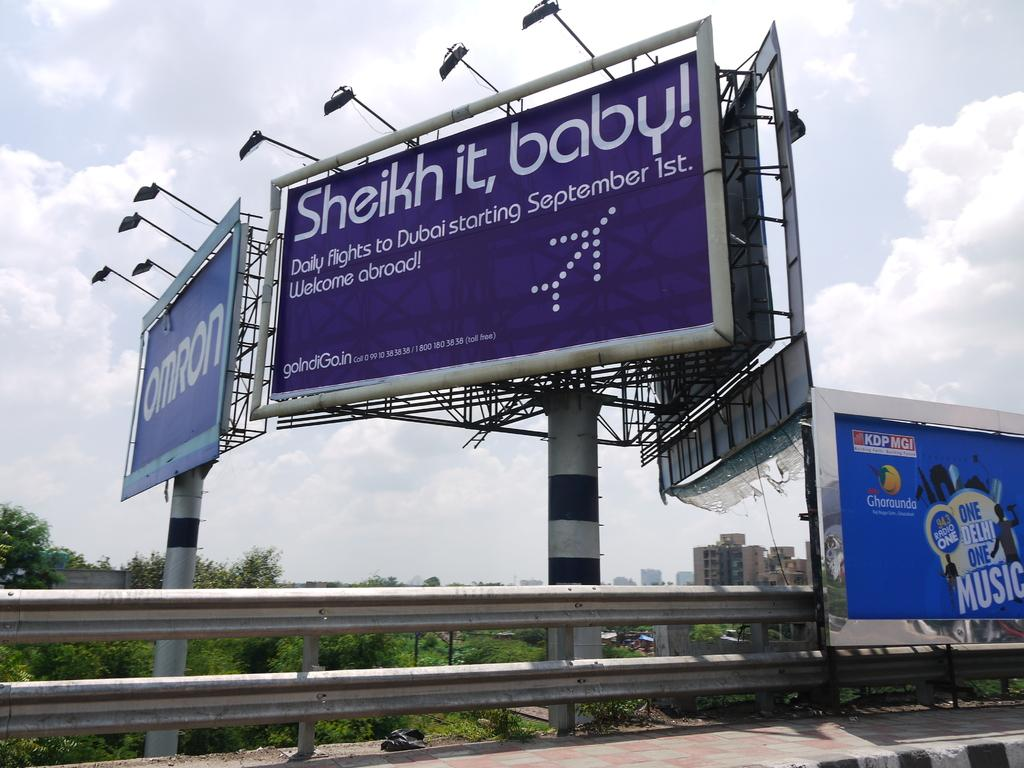<image>
Provide a brief description of the given image. The poster advertised flights to Dubai starting in September. 